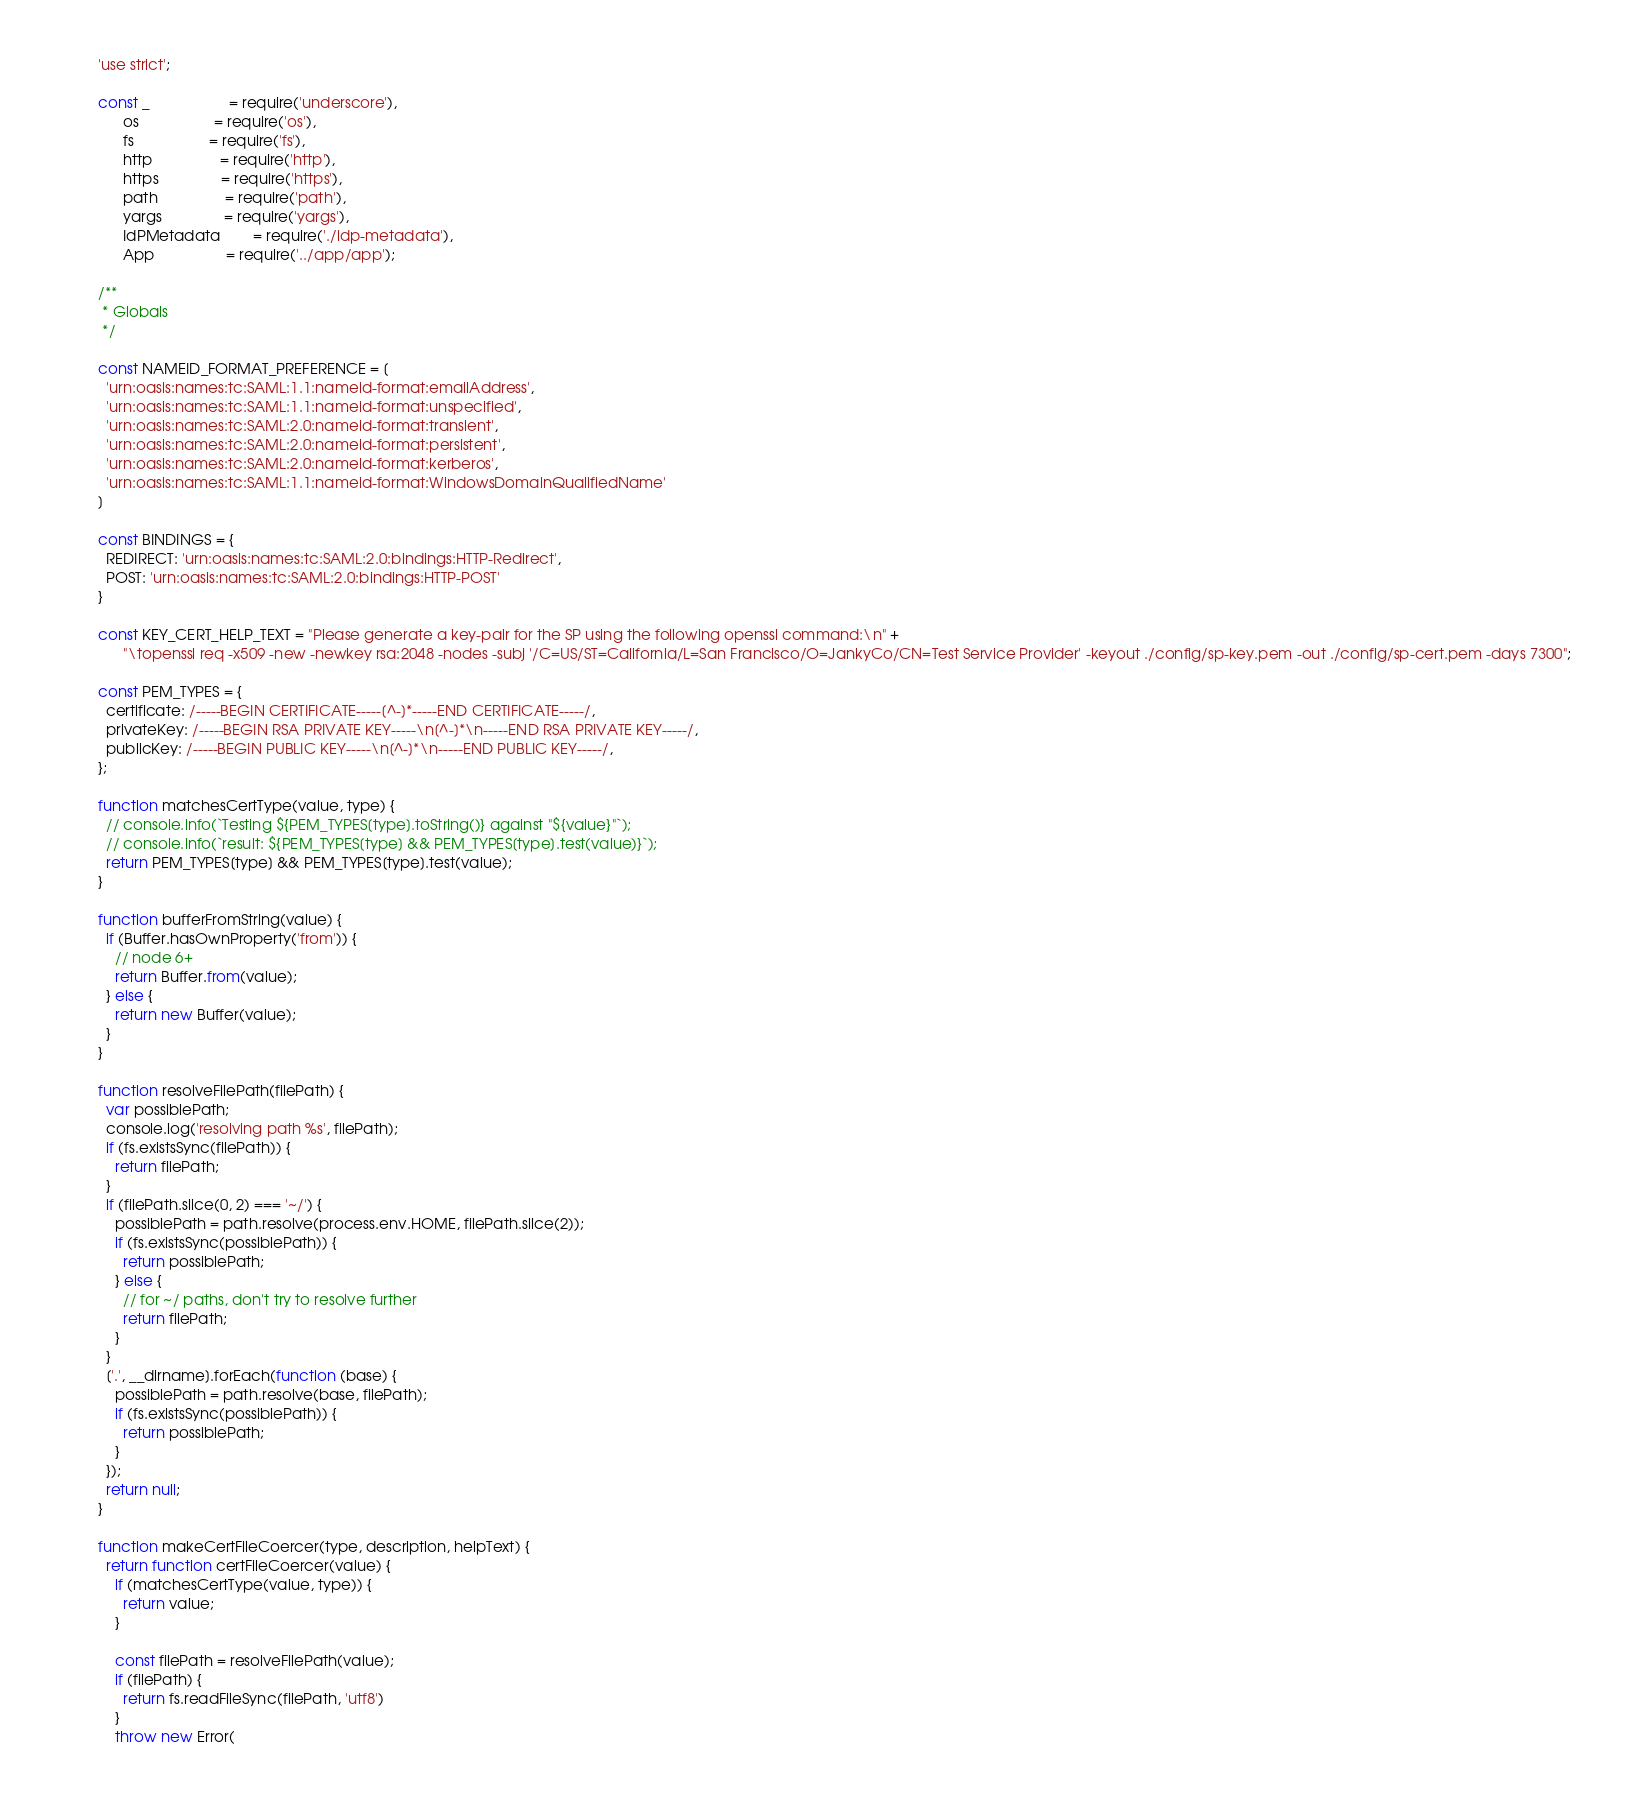Convert code to text. <code><loc_0><loc_0><loc_500><loc_500><_JavaScript_>'use strict';

const _                   = require('underscore'),
      os                  = require('os'),
      fs                  = require('fs'),
      http                = require('http'),
      https               = require('https'),
      path                = require('path'),
      yargs               = require('yargs'),
      IdPMetadata        = require('./idp-metadata'),
      App                 = require('../app/app');

/**
 * Globals
 */

const NAMEID_FORMAT_PREFERENCE = [
  'urn:oasis:names:tc:SAML:1.1:nameid-format:emailAddress',
  'urn:oasis:names:tc:SAML:1.1:nameid-format:unspecified',
  'urn:oasis:names:tc:SAML:2.0:nameid-format:transient',
  'urn:oasis:names:tc:SAML:2.0:nameid-format:persistent',
  'urn:oasis:names:tc:SAML:2.0:nameid-format:kerberos',
  'urn:oasis:names:tc:SAML:1.1:nameid-format:WindowsDomainQualifiedName'
]

const BINDINGS = {
  REDIRECT: 'urn:oasis:names:tc:SAML:2.0:bindings:HTTP-Redirect',
  POST: 'urn:oasis:names:tc:SAML:2.0:bindings:HTTP-POST'
}

const KEY_CERT_HELP_TEXT = "Please generate a key-pair for the SP using the following openssl command:\n" +
      "\topenssl req -x509 -new -newkey rsa:2048 -nodes -subj '/C=US/ST=California/L=San Francisco/O=JankyCo/CN=Test Service Provider' -keyout ./config/sp-key.pem -out ./config/sp-cert.pem -days 7300";

const PEM_TYPES = {
  certificate: /-----BEGIN CERTIFICATE-----[^-]*-----END CERTIFICATE-----/,
  privateKey: /-----BEGIN RSA PRIVATE KEY-----\n[^-]*\n-----END RSA PRIVATE KEY-----/,
  publicKey: /-----BEGIN PUBLIC KEY-----\n[^-]*\n-----END PUBLIC KEY-----/,
};

function matchesCertType(value, type) {
  // console.info(`Testing ${PEM_TYPES[type].toString()} against "${value}"`);
  // console.info(`result: ${PEM_TYPES[type] && PEM_TYPES[type].test(value)}`);
  return PEM_TYPES[type] && PEM_TYPES[type].test(value);
}

function bufferFromString(value) {
  if (Buffer.hasOwnProperty('from')) {
    // node 6+
    return Buffer.from(value);
  } else {
    return new Buffer(value);
  }
}

function resolveFilePath(filePath) {
  var possiblePath;
  console.log('resolving path %s', filePath);
  if (fs.existsSync(filePath)) {
    return filePath;
  }
  if (filePath.slice(0, 2) === '~/') {
    possiblePath = path.resolve(process.env.HOME, filePath.slice(2));
    if (fs.existsSync(possiblePath)) {
      return possiblePath;
    } else {
      // for ~/ paths, don't try to resolve further
      return filePath;
    }
  }
  ['.', __dirname].forEach(function (base) {
    possiblePath = path.resolve(base, filePath);
    if (fs.existsSync(possiblePath)) {
      return possiblePath;
    }
  });
  return null;
}

function makeCertFileCoercer(type, description, helpText) {
  return function certFileCoercer(value) {
    if (matchesCertType(value, type)) {
      return value;
    }

    const filePath = resolveFilePath(value);
    if (filePath) {
      return fs.readFileSync(filePath, 'utf8')
    }
    throw new Error(</code> 